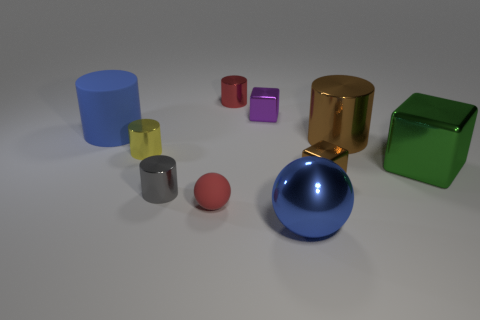Subtract all big shiny cylinders. How many cylinders are left? 4 Subtract all red cylinders. How many cylinders are left? 4 Subtract all brown blocks. Subtract all blue spheres. How many blocks are left? 2 Subtract all blocks. How many objects are left? 7 Subtract all tiny red cylinders. Subtract all big green metallic cubes. How many objects are left? 8 Add 2 tiny yellow cylinders. How many tiny yellow cylinders are left? 3 Add 2 large brown shiny things. How many large brown shiny things exist? 3 Subtract 1 blue spheres. How many objects are left? 9 